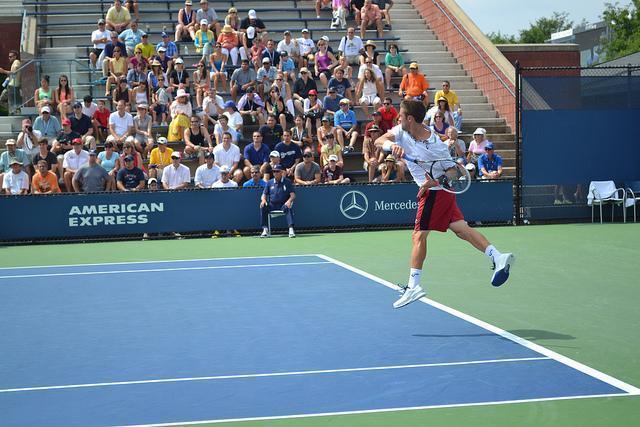Which company has sponsored this event?
Select the accurate answer and provide explanation: 'Answer: answer
Rationale: rationale.'
Options: American express, bmw, sony, visa. Answer: american express.
Rationale: It's clearly written on the wall. 